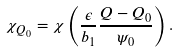<formula> <loc_0><loc_0><loc_500><loc_500>\chi _ { Q _ { 0 } } = \chi \left ( \frac { \epsilon } { b _ { 1 } } \frac { Q - Q _ { 0 } } { \psi _ { 0 } } \right ) .</formula> 